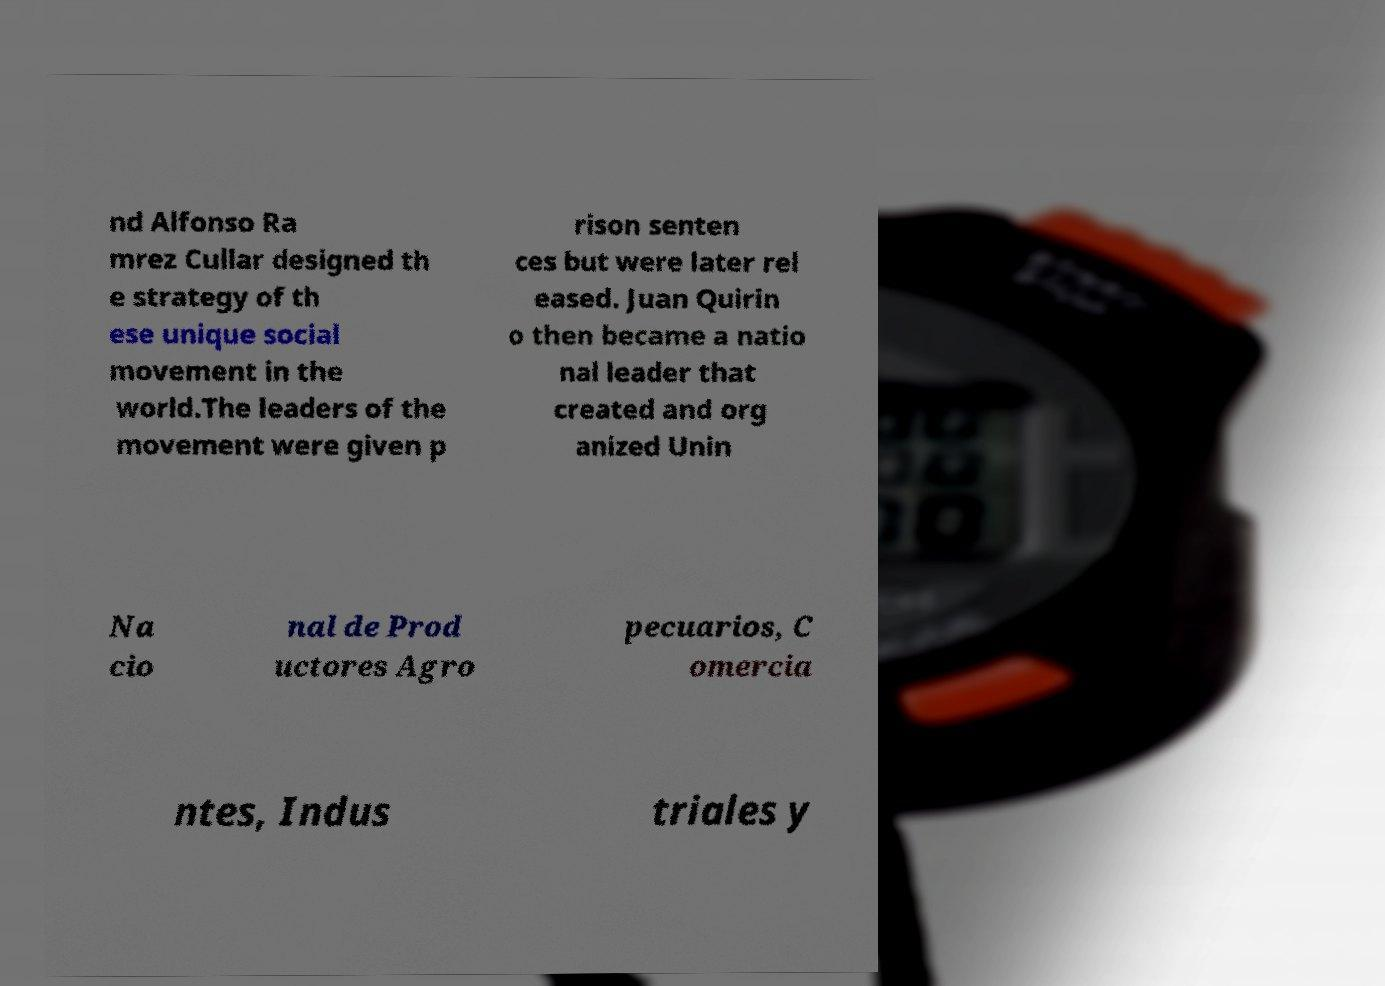What messages or text are displayed in this image? I need them in a readable, typed format. nd Alfonso Ra mrez Cullar designed th e strategy of th ese unique social movement in the world.The leaders of the movement were given p rison senten ces but were later rel eased. Juan Quirin o then became a natio nal leader that created and org anized Unin Na cio nal de Prod uctores Agro pecuarios, C omercia ntes, Indus triales y 